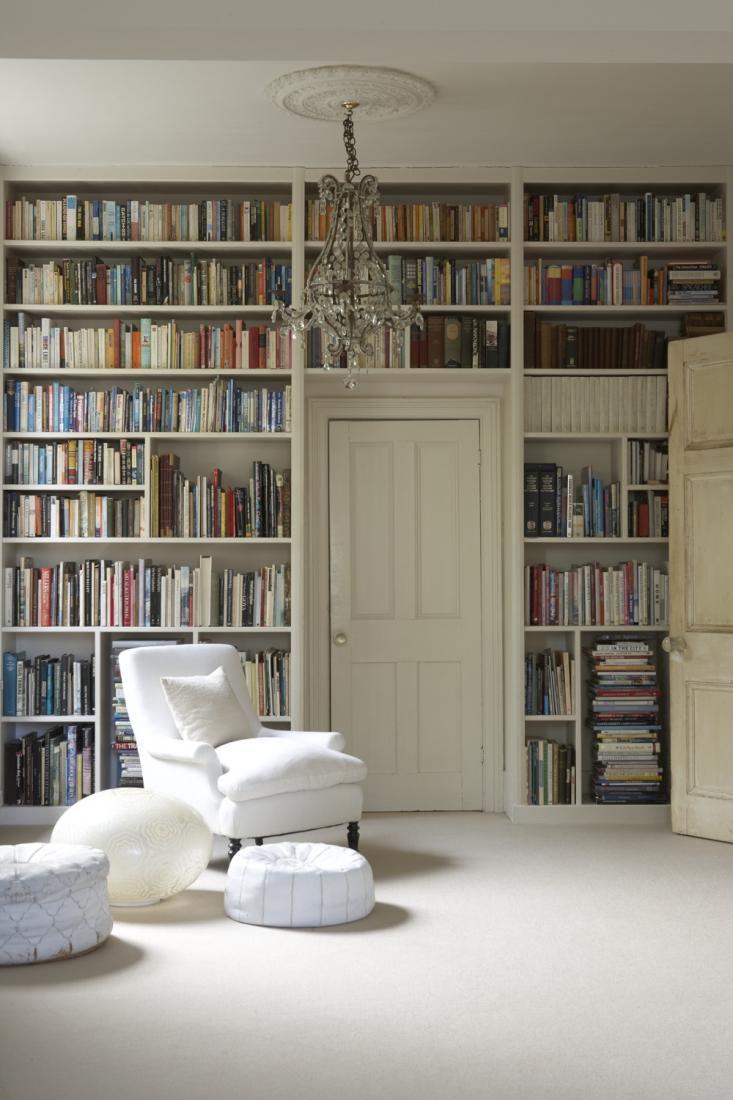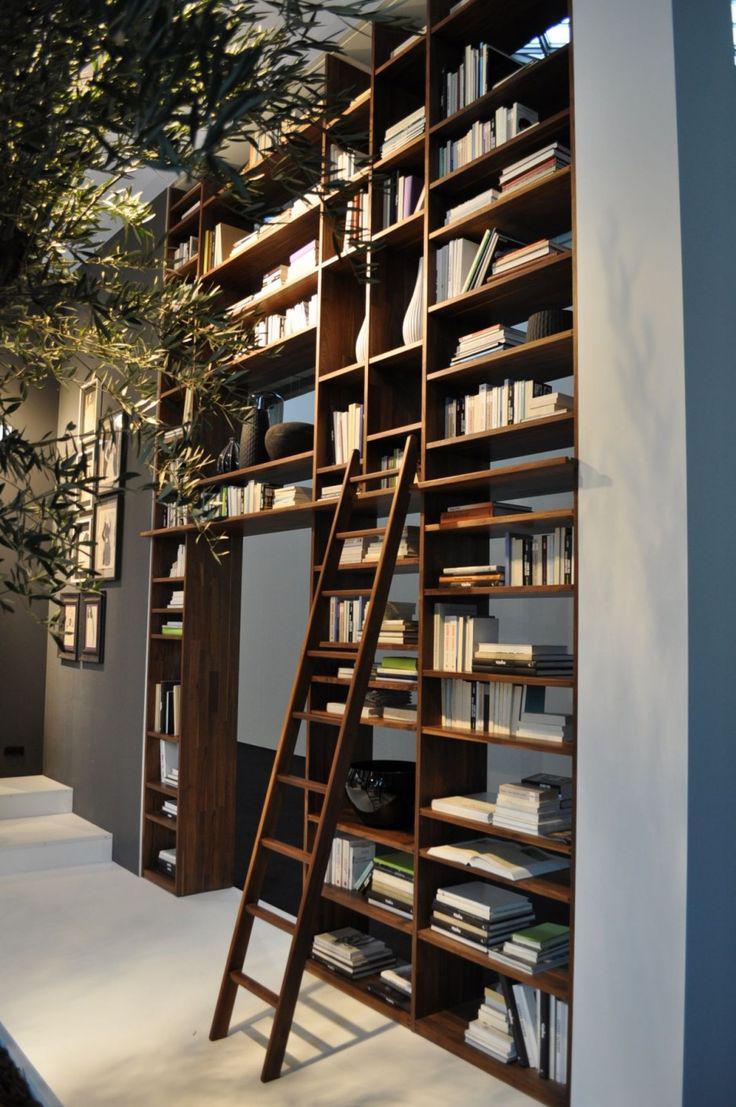The first image is the image on the left, the second image is the image on the right. For the images shown, is this caption "There is exactly one ladder." true? Answer yes or no. Yes. The first image is the image on the left, the second image is the image on the right. Considering the images on both sides, is "The right image shows a white ladder leaned against an upper shelf of a bookcase." valid? Answer yes or no. No. 